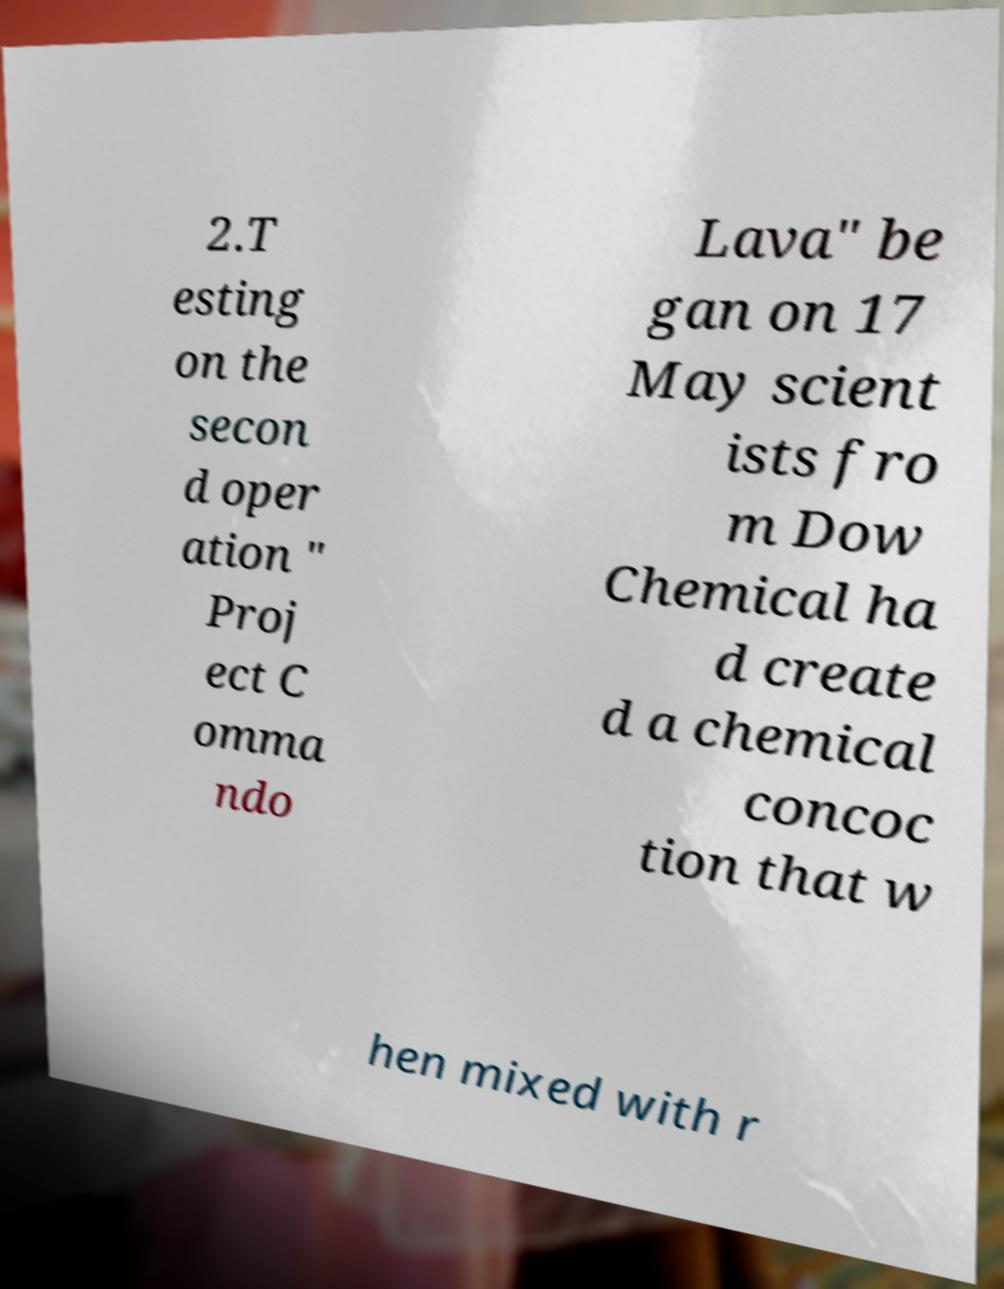Please identify and transcribe the text found in this image. 2.T esting on the secon d oper ation " Proj ect C omma ndo Lava" be gan on 17 May scient ists fro m Dow Chemical ha d create d a chemical concoc tion that w hen mixed with r 